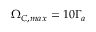Convert formula to latex. <formula><loc_0><loc_0><loc_500><loc_500>\Omega _ { C , \max } = 1 0 \Gamma _ { a }</formula> 